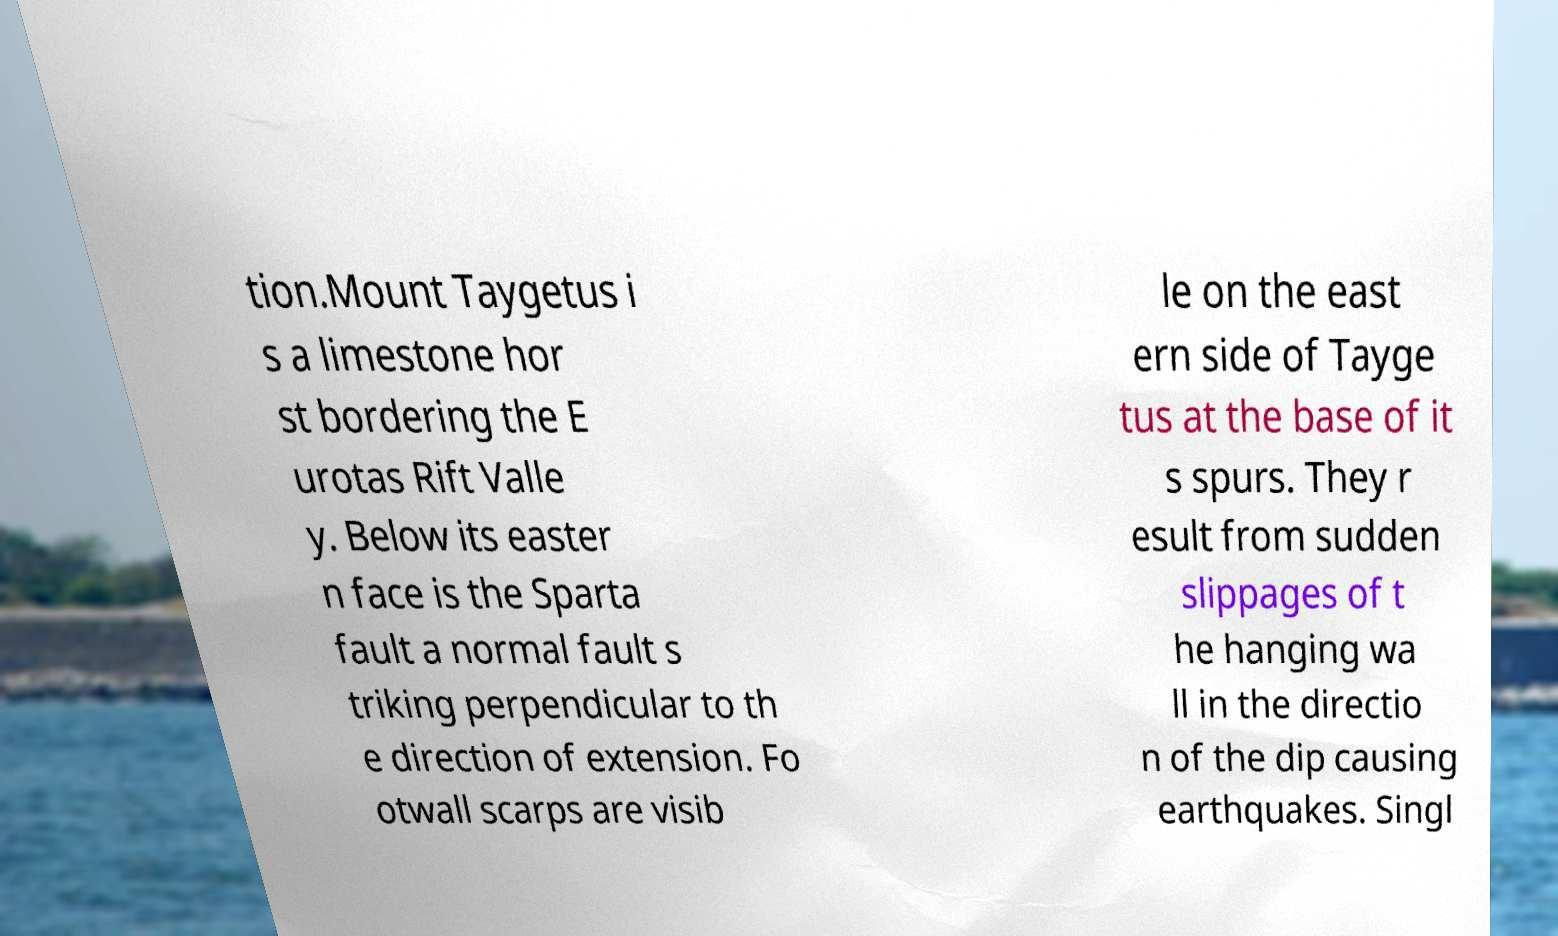Please identify and transcribe the text found in this image. tion.Mount Taygetus i s a limestone hor st bordering the E urotas Rift Valle y. Below its easter n face is the Sparta fault a normal fault s triking perpendicular to th e direction of extension. Fo otwall scarps are visib le on the east ern side of Tayge tus at the base of it s spurs. They r esult from sudden slippages of t he hanging wa ll in the directio n of the dip causing earthquakes. Singl 